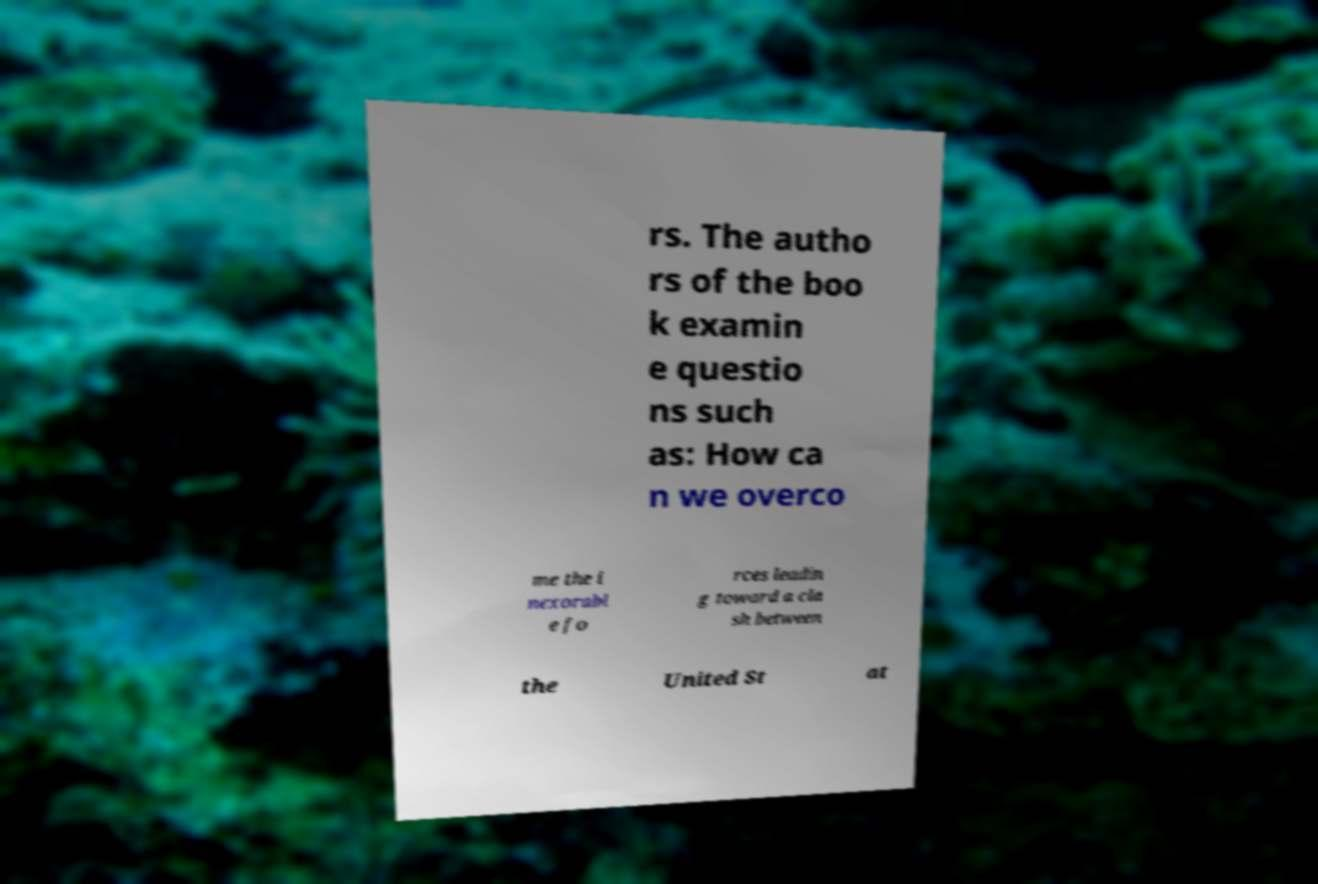Can you accurately transcribe the text from the provided image for me? rs. The autho rs of the boo k examin e questio ns such as: How ca n we overco me the i nexorabl e fo rces leadin g toward a cla sh between the United St at 